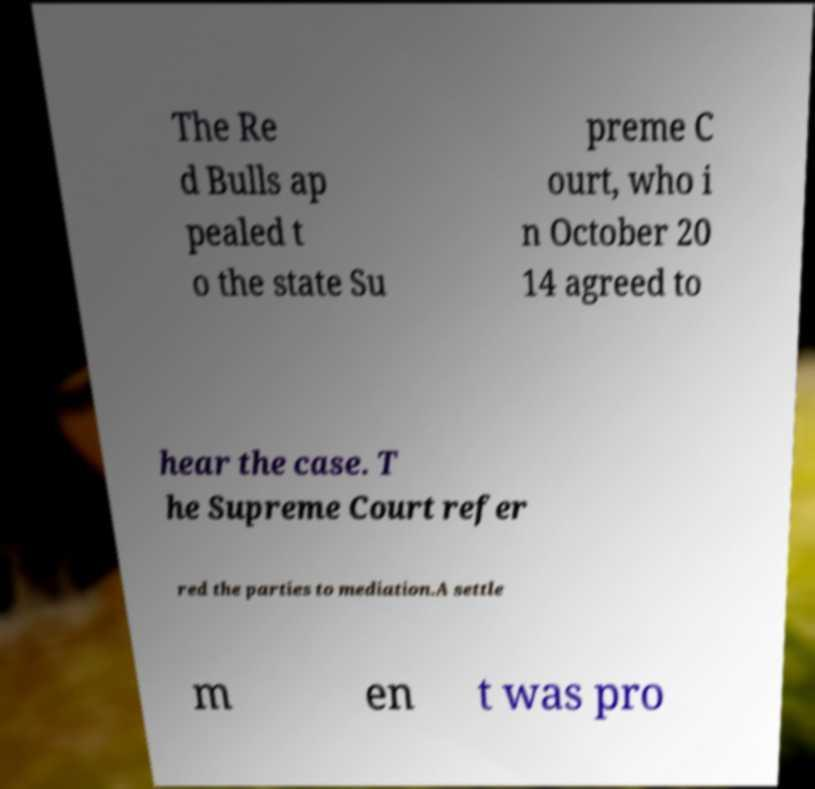Can you read and provide the text displayed in the image?This photo seems to have some interesting text. Can you extract and type it out for me? The Re d Bulls ap pealed t o the state Su preme C ourt, who i n October 20 14 agreed to hear the case. T he Supreme Court refer red the parties to mediation.A settle m en t was pro 